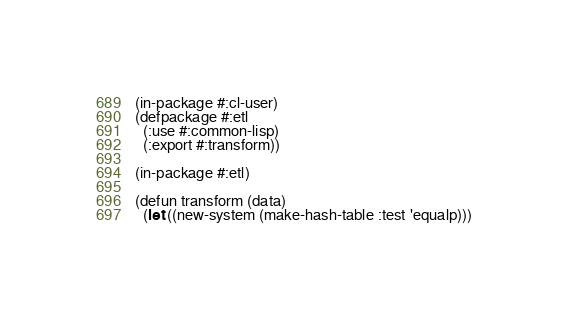<code> <loc_0><loc_0><loc_500><loc_500><_Lisp_>(in-package #:cl-user)
(defpackage #:etl
  (:use #:common-lisp)
  (:export #:transform))

(in-package #:etl)

(defun transform (data)
  (let ((new-system (make-hash-table :test 'equalp)))</code> 